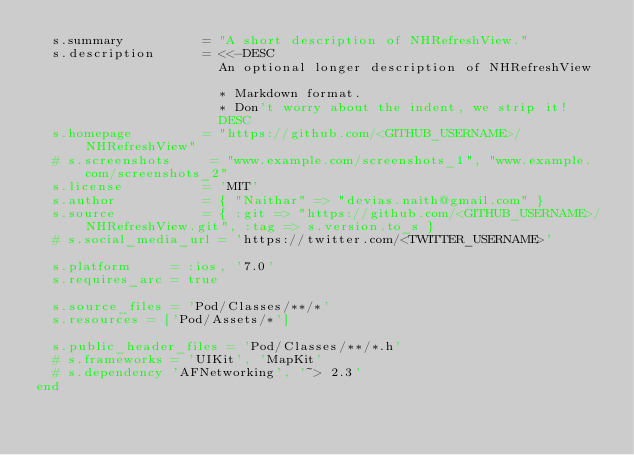<code> <loc_0><loc_0><loc_500><loc_500><_Ruby_>  s.summary          = "A short description of NHRefreshView."
  s.description      = <<-DESC
                       An optional longer description of NHRefreshView

                       * Markdown format.
                       * Don't worry about the indent, we strip it!
                       DESC
  s.homepage         = "https://github.com/<GITHUB_USERNAME>/NHRefreshView"
  # s.screenshots     = "www.example.com/screenshots_1", "www.example.com/screenshots_2"
  s.license          = 'MIT'
  s.author           = { "Naithar" => "devias.naith@gmail.com" }
  s.source           = { :git => "https://github.com/<GITHUB_USERNAME>/NHRefreshView.git", :tag => s.version.to_s }
  # s.social_media_url = 'https://twitter.com/<TWITTER_USERNAME>'

  s.platform     = :ios, '7.0'
  s.requires_arc = true

  s.source_files = 'Pod/Classes/**/*'
  s.resources = ['Pod/Assets/*']

  s.public_header_files = 'Pod/Classes/**/*.h'
  # s.frameworks = 'UIKit', 'MapKit'
  # s.dependency 'AFNetworking', '~> 2.3'
end
</code> 